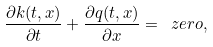<formula> <loc_0><loc_0><loc_500><loc_500>\frac { \partial k ( t , x ) } { \partial t } + \frac { \partial q ( t , x ) } { \partial x } = \ z e r o ,</formula> 